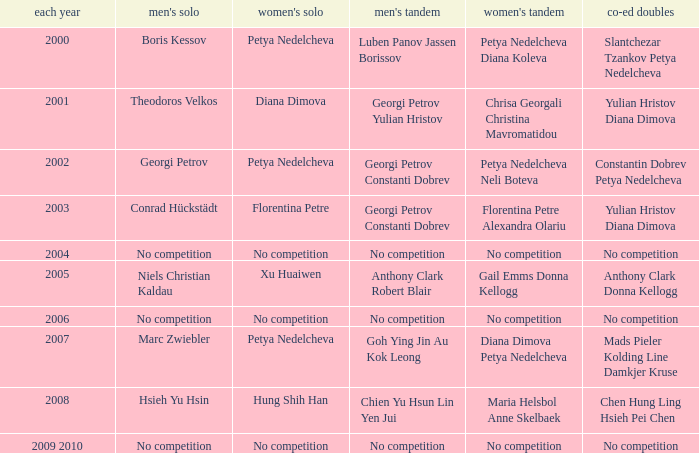Who won the Men's Double the same year as Florentina Petre winning the Women's Singles? Georgi Petrov Constanti Dobrev. 